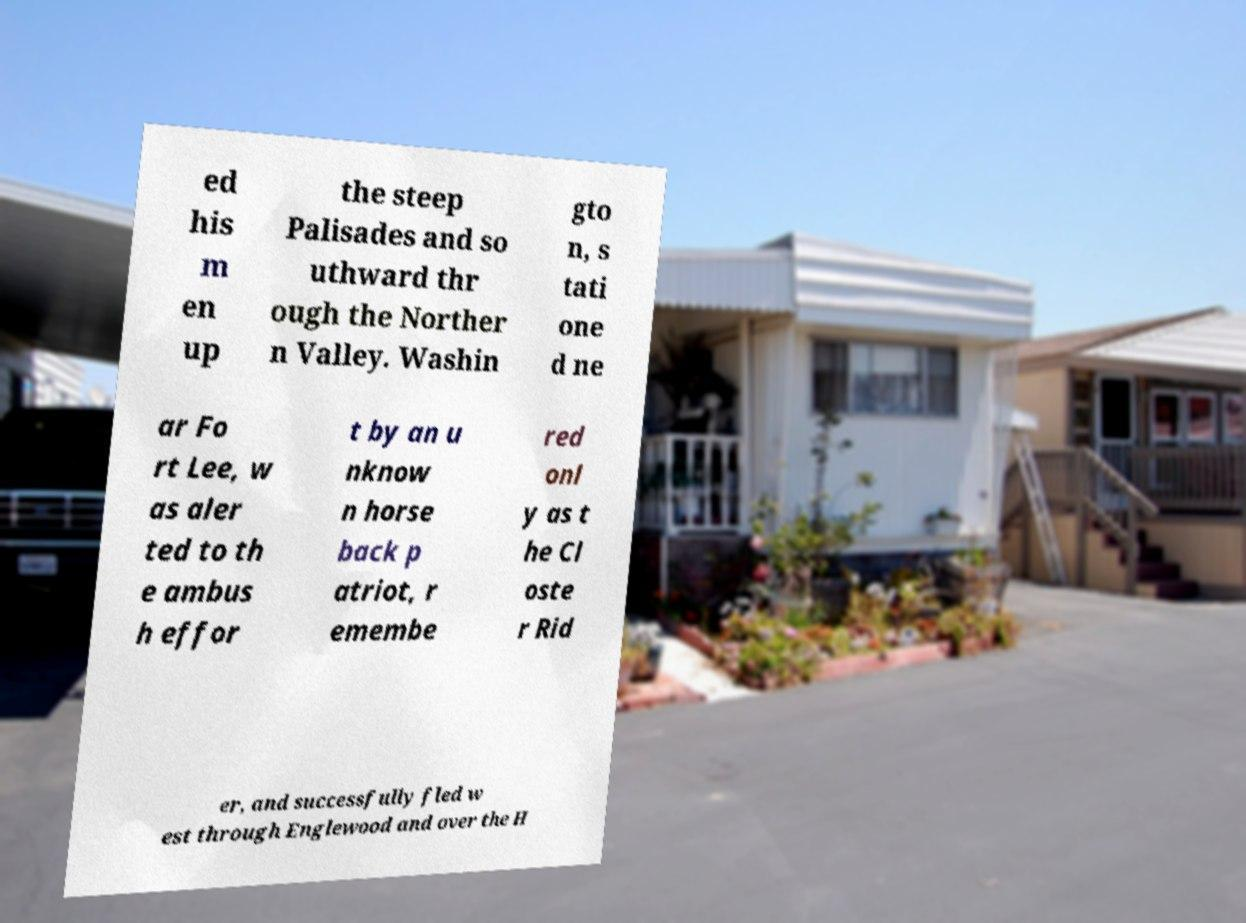What messages or text are displayed in this image? I need them in a readable, typed format. ed his m en up the steep Palisades and so uthward thr ough the Norther n Valley. Washin gto n, s tati one d ne ar Fo rt Lee, w as aler ted to th e ambus h effor t by an u nknow n horse back p atriot, r emembe red onl y as t he Cl oste r Rid er, and successfully fled w est through Englewood and over the H 